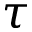<formula> <loc_0><loc_0><loc_500><loc_500>\tau</formula> 